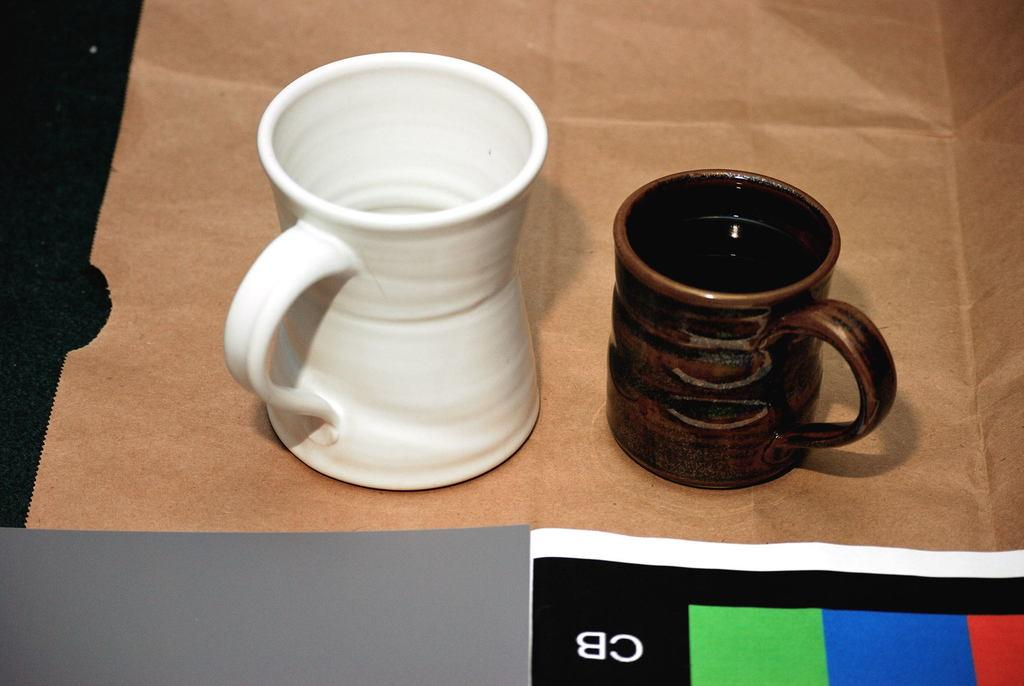<image>
Render a clear and concise summary of the photo. A white and a brown coffee mug sit on a paper bag with a paper underneath them that says CB on it. 